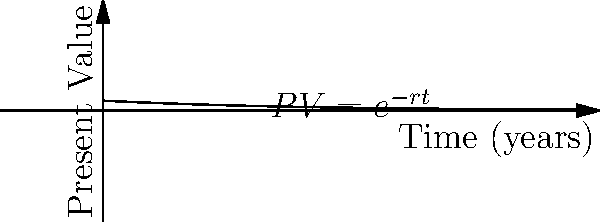As a policy analyst studying the long-term effects of climate change mitigation strategies, you need to calculate the present value of future policy outcomes. Given the exponential decay function $PV = e^{-rt}$, where $r$ is the discount rate of 5% per year and $t$ is the time in years, what is the present value of a $1 million climate resilience benefit expected to occur in 30 years? To solve this problem, we'll follow these steps:

1) The given formula for present value is:
   $PV = e^{-rt}$

2) We're given:
   $r = 5\% = 0.05$ (discount rate)
   $t = 30$ years
   Future value = $1 million

3) Plug these values into the formula:
   $PV = e^{-0.05 * 30}$

4) Simplify the exponent:
   $PV = e^{-1.5}$

5) Calculate this value:
   $PV \approx 0.2231$

6) This means the present value is about 22.31% of the future value.

7) Calculate the final present value:
   $0.2231 * \$1,000,000 = \$223,100$

Therefore, the present value of a $1 million benefit occurring in 30 years, with a 5% annual discount rate, is approximately $223,100.
Answer: $223,100 